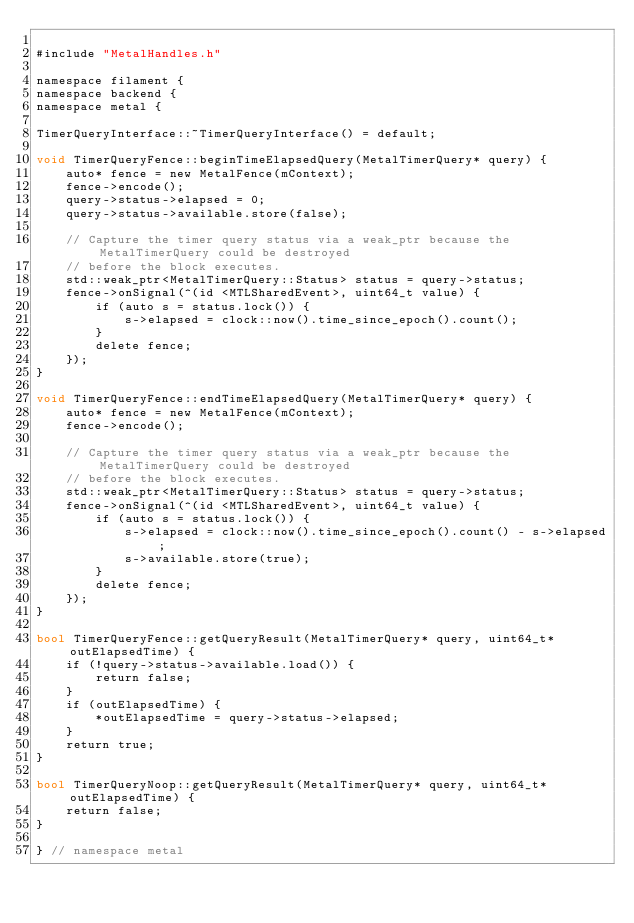<code> <loc_0><loc_0><loc_500><loc_500><_ObjectiveC_>
#include "MetalHandles.h"

namespace filament {
namespace backend {
namespace metal {

TimerQueryInterface::~TimerQueryInterface() = default;

void TimerQueryFence::beginTimeElapsedQuery(MetalTimerQuery* query) {
    auto* fence = new MetalFence(mContext);
    fence->encode();
    query->status->elapsed = 0;
    query->status->available.store(false);

    // Capture the timer query status via a weak_ptr because the MetalTimerQuery could be destroyed
    // before the block executes.
    std::weak_ptr<MetalTimerQuery::Status> status = query->status;
    fence->onSignal(^(id <MTLSharedEvent>, uint64_t value) {
        if (auto s = status.lock()) {
            s->elapsed = clock::now().time_since_epoch().count();
        }
        delete fence;
    });
}

void TimerQueryFence::endTimeElapsedQuery(MetalTimerQuery* query) {
    auto* fence = new MetalFence(mContext);
    fence->encode();

    // Capture the timer query status via a weak_ptr because the MetalTimerQuery could be destroyed
    // before the block executes.
    std::weak_ptr<MetalTimerQuery::Status> status = query->status;
    fence->onSignal(^(id <MTLSharedEvent>, uint64_t value) {
        if (auto s = status.lock()) {
            s->elapsed = clock::now().time_since_epoch().count() - s->elapsed;
            s->available.store(true);
        }
        delete fence;
    });
}

bool TimerQueryFence::getQueryResult(MetalTimerQuery* query, uint64_t* outElapsedTime) {
    if (!query->status->available.load()) {
        return false;
    }
    if (outElapsedTime) {
        *outElapsedTime = query->status->elapsed;
    }
    return true;
}

bool TimerQueryNoop::getQueryResult(MetalTimerQuery* query, uint64_t* outElapsedTime) {
    return false;
}

} // namespace metal</code> 